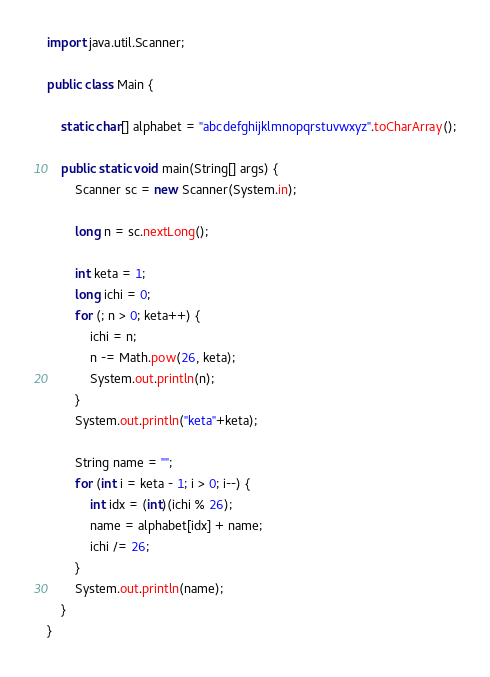<code> <loc_0><loc_0><loc_500><loc_500><_Java_>import java.util.Scanner;

public class Main {

    static char[] alphabet = "abcdefghijklmnopqrstuvwxyz".toCharArray();

    public static void main(String[] args) {
        Scanner sc = new Scanner(System.in);

        long n = sc.nextLong();
        
        int keta = 1;
        long ichi = 0;
        for (; n > 0; keta++) {
            ichi = n;
            n -= Math.pow(26, keta);
            System.out.println(n);
        }
        System.out.println("keta"+keta);

        String name = "";
        for (int i = keta - 1; i > 0; i--) {
            int idx = (int)(ichi % 26);
            name = alphabet[idx] + name;
            ichi /= 26;
        }
        System.out.println(name);
    }
}
</code> 